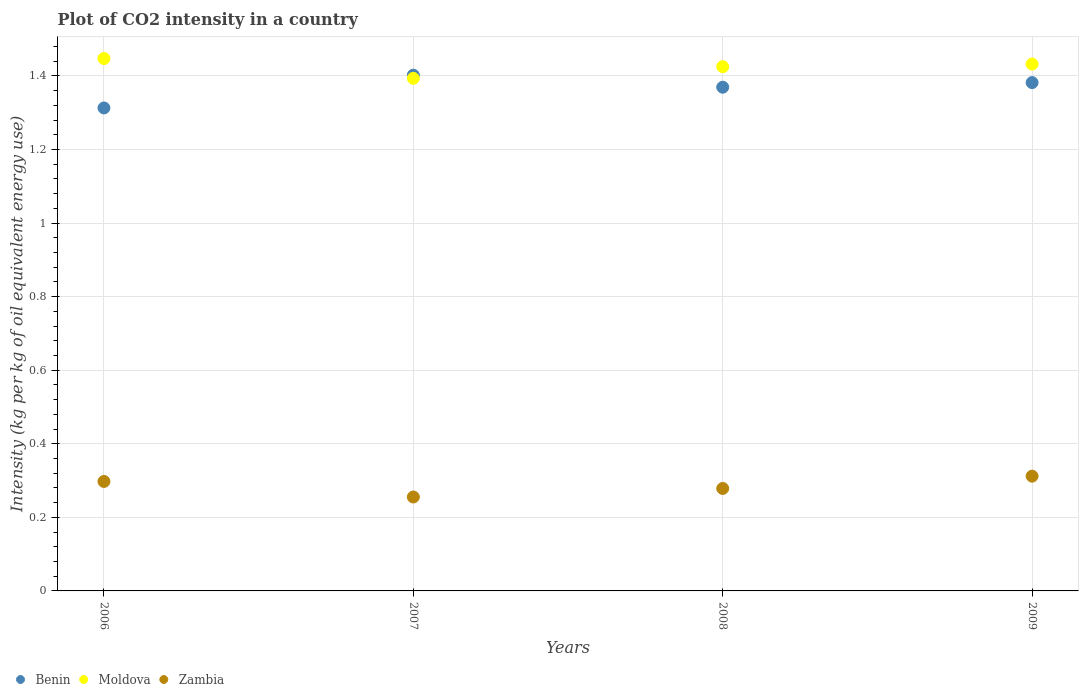What is the CO2 intensity in in Moldova in 2007?
Your response must be concise. 1.39. Across all years, what is the maximum CO2 intensity in in Zambia?
Ensure brevity in your answer.  0.31. Across all years, what is the minimum CO2 intensity in in Benin?
Offer a terse response. 1.31. In which year was the CO2 intensity in in Moldova minimum?
Give a very brief answer. 2007. What is the total CO2 intensity in in Moldova in the graph?
Provide a succinct answer. 5.7. What is the difference between the CO2 intensity in in Zambia in 2006 and that in 2009?
Your answer should be very brief. -0.01. What is the difference between the CO2 intensity in in Moldova in 2008 and the CO2 intensity in in Zambia in 2007?
Your response must be concise. 1.17. What is the average CO2 intensity in in Benin per year?
Your answer should be compact. 1.37. In the year 2007, what is the difference between the CO2 intensity in in Moldova and CO2 intensity in in Zambia?
Offer a terse response. 1.14. In how many years, is the CO2 intensity in in Moldova greater than 0.48000000000000004 kg?
Keep it short and to the point. 4. What is the ratio of the CO2 intensity in in Benin in 2008 to that in 2009?
Keep it short and to the point. 0.99. What is the difference between the highest and the second highest CO2 intensity in in Moldova?
Provide a succinct answer. 0.02. What is the difference between the highest and the lowest CO2 intensity in in Zambia?
Ensure brevity in your answer.  0.06. Is the sum of the CO2 intensity in in Zambia in 2006 and 2009 greater than the maximum CO2 intensity in in Benin across all years?
Ensure brevity in your answer.  No. How many dotlines are there?
Offer a terse response. 3. How many years are there in the graph?
Make the answer very short. 4. What is the difference between two consecutive major ticks on the Y-axis?
Give a very brief answer. 0.2. How are the legend labels stacked?
Your answer should be very brief. Horizontal. What is the title of the graph?
Offer a terse response. Plot of CO2 intensity in a country. What is the label or title of the Y-axis?
Keep it short and to the point. Intensity (kg per kg of oil equivalent energy use). What is the Intensity (kg per kg of oil equivalent energy use) in Benin in 2006?
Offer a very short reply. 1.31. What is the Intensity (kg per kg of oil equivalent energy use) in Moldova in 2006?
Offer a very short reply. 1.45. What is the Intensity (kg per kg of oil equivalent energy use) of Zambia in 2006?
Give a very brief answer. 0.3. What is the Intensity (kg per kg of oil equivalent energy use) of Benin in 2007?
Ensure brevity in your answer.  1.4. What is the Intensity (kg per kg of oil equivalent energy use) of Moldova in 2007?
Ensure brevity in your answer.  1.39. What is the Intensity (kg per kg of oil equivalent energy use) in Zambia in 2007?
Offer a very short reply. 0.26. What is the Intensity (kg per kg of oil equivalent energy use) of Benin in 2008?
Your answer should be compact. 1.37. What is the Intensity (kg per kg of oil equivalent energy use) of Moldova in 2008?
Offer a very short reply. 1.43. What is the Intensity (kg per kg of oil equivalent energy use) in Zambia in 2008?
Your answer should be very brief. 0.28. What is the Intensity (kg per kg of oil equivalent energy use) of Benin in 2009?
Your response must be concise. 1.38. What is the Intensity (kg per kg of oil equivalent energy use) in Moldova in 2009?
Your answer should be compact. 1.43. What is the Intensity (kg per kg of oil equivalent energy use) of Zambia in 2009?
Keep it short and to the point. 0.31. Across all years, what is the maximum Intensity (kg per kg of oil equivalent energy use) in Benin?
Provide a short and direct response. 1.4. Across all years, what is the maximum Intensity (kg per kg of oil equivalent energy use) of Moldova?
Keep it short and to the point. 1.45. Across all years, what is the maximum Intensity (kg per kg of oil equivalent energy use) of Zambia?
Your answer should be very brief. 0.31. Across all years, what is the minimum Intensity (kg per kg of oil equivalent energy use) of Benin?
Provide a succinct answer. 1.31. Across all years, what is the minimum Intensity (kg per kg of oil equivalent energy use) in Moldova?
Give a very brief answer. 1.39. Across all years, what is the minimum Intensity (kg per kg of oil equivalent energy use) in Zambia?
Ensure brevity in your answer.  0.26. What is the total Intensity (kg per kg of oil equivalent energy use) of Benin in the graph?
Give a very brief answer. 5.47. What is the total Intensity (kg per kg of oil equivalent energy use) in Moldova in the graph?
Ensure brevity in your answer.  5.7. What is the total Intensity (kg per kg of oil equivalent energy use) in Zambia in the graph?
Make the answer very short. 1.14. What is the difference between the Intensity (kg per kg of oil equivalent energy use) of Benin in 2006 and that in 2007?
Keep it short and to the point. -0.09. What is the difference between the Intensity (kg per kg of oil equivalent energy use) of Moldova in 2006 and that in 2007?
Offer a terse response. 0.05. What is the difference between the Intensity (kg per kg of oil equivalent energy use) of Zambia in 2006 and that in 2007?
Ensure brevity in your answer.  0.04. What is the difference between the Intensity (kg per kg of oil equivalent energy use) in Benin in 2006 and that in 2008?
Offer a very short reply. -0.06. What is the difference between the Intensity (kg per kg of oil equivalent energy use) in Moldova in 2006 and that in 2008?
Offer a terse response. 0.02. What is the difference between the Intensity (kg per kg of oil equivalent energy use) of Zambia in 2006 and that in 2008?
Your answer should be compact. 0.02. What is the difference between the Intensity (kg per kg of oil equivalent energy use) of Benin in 2006 and that in 2009?
Your answer should be compact. -0.07. What is the difference between the Intensity (kg per kg of oil equivalent energy use) in Moldova in 2006 and that in 2009?
Give a very brief answer. 0.02. What is the difference between the Intensity (kg per kg of oil equivalent energy use) in Zambia in 2006 and that in 2009?
Offer a very short reply. -0.01. What is the difference between the Intensity (kg per kg of oil equivalent energy use) of Benin in 2007 and that in 2008?
Your answer should be compact. 0.03. What is the difference between the Intensity (kg per kg of oil equivalent energy use) of Moldova in 2007 and that in 2008?
Provide a succinct answer. -0.03. What is the difference between the Intensity (kg per kg of oil equivalent energy use) of Zambia in 2007 and that in 2008?
Your response must be concise. -0.02. What is the difference between the Intensity (kg per kg of oil equivalent energy use) in Benin in 2007 and that in 2009?
Offer a terse response. 0.02. What is the difference between the Intensity (kg per kg of oil equivalent energy use) in Moldova in 2007 and that in 2009?
Offer a very short reply. -0.04. What is the difference between the Intensity (kg per kg of oil equivalent energy use) of Zambia in 2007 and that in 2009?
Offer a terse response. -0.06. What is the difference between the Intensity (kg per kg of oil equivalent energy use) of Benin in 2008 and that in 2009?
Offer a very short reply. -0.01. What is the difference between the Intensity (kg per kg of oil equivalent energy use) of Moldova in 2008 and that in 2009?
Offer a terse response. -0.01. What is the difference between the Intensity (kg per kg of oil equivalent energy use) in Zambia in 2008 and that in 2009?
Provide a short and direct response. -0.03. What is the difference between the Intensity (kg per kg of oil equivalent energy use) in Benin in 2006 and the Intensity (kg per kg of oil equivalent energy use) in Moldova in 2007?
Your answer should be very brief. -0.08. What is the difference between the Intensity (kg per kg of oil equivalent energy use) in Benin in 2006 and the Intensity (kg per kg of oil equivalent energy use) in Zambia in 2007?
Give a very brief answer. 1.06. What is the difference between the Intensity (kg per kg of oil equivalent energy use) in Moldova in 2006 and the Intensity (kg per kg of oil equivalent energy use) in Zambia in 2007?
Your answer should be compact. 1.19. What is the difference between the Intensity (kg per kg of oil equivalent energy use) of Benin in 2006 and the Intensity (kg per kg of oil equivalent energy use) of Moldova in 2008?
Your response must be concise. -0.11. What is the difference between the Intensity (kg per kg of oil equivalent energy use) in Benin in 2006 and the Intensity (kg per kg of oil equivalent energy use) in Zambia in 2008?
Make the answer very short. 1.03. What is the difference between the Intensity (kg per kg of oil equivalent energy use) of Moldova in 2006 and the Intensity (kg per kg of oil equivalent energy use) of Zambia in 2008?
Offer a very short reply. 1.17. What is the difference between the Intensity (kg per kg of oil equivalent energy use) of Benin in 2006 and the Intensity (kg per kg of oil equivalent energy use) of Moldova in 2009?
Offer a terse response. -0.12. What is the difference between the Intensity (kg per kg of oil equivalent energy use) in Benin in 2006 and the Intensity (kg per kg of oil equivalent energy use) in Zambia in 2009?
Ensure brevity in your answer.  1. What is the difference between the Intensity (kg per kg of oil equivalent energy use) of Moldova in 2006 and the Intensity (kg per kg of oil equivalent energy use) of Zambia in 2009?
Provide a short and direct response. 1.14. What is the difference between the Intensity (kg per kg of oil equivalent energy use) in Benin in 2007 and the Intensity (kg per kg of oil equivalent energy use) in Moldova in 2008?
Your response must be concise. -0.02. What is the difference between the Intensity (kg per kg of oil equivalent energy use) of Benin in 2007 and the Intensity (kg per kg of oil equivalent energy use) of Zambia in 2008?
Keep it short and to the point. 1.12. What is the difference between the Intensity (kg per kg of oil equivalent energy use) of Moldova in 2007 and the Intensity (kg per kg of oil equivalent energy use) of Zambia in 2008?
Your response must be concise. 1.12. What is the difference between the Intensity (kg per kg of oil equivalent energy use) of Benin in 2007 and the Intensity (kg per kg of oil equivalent energy use) of Moldova in 2009?
Your answer should be compact. -0.03. What is the difference between the Intensity (kg per kg of oil equivalent energy use) in Benin in 2007 and the Intensity (kg per kg of oil equivalent energy use) in Zambia in 2009?
Provide a succinct answer. 1.09. What is the difference between the Intensity (kg per kg of oil equivalent energy use) of Moldova in 2007 and the Intensity (kg per kg of oil equivalent energy use) of Zambia in 2009?
Keep it short and to the point. 1.08. What is the difference between the Intensity (kg per kg of oil equivalent energy use) of Benin in 2008 and the Intensity (kg per kg of oil equivalent energy use) of Moldova in 2009?
Offer a terse response. -0.06. What is the difference between the Intensity (kg per kg of oil equivalent energy use) in Benin in 2008 and the Intensity (kg per kg of oil equivalent energy use) in Zambia in 2009?
Keep it short and to the point. 1.06. What is the difference between the Intensity (kg per kg of oil equivalent energy use) of Moldova in 2008 and the Intensity (kg per kg of oil equivalent energy use) of Zambia in 2009?
Offer a very short reply. 1.11. What is the average Intensity (kg per kg of oil equivalent energy use) in Benin per year?
Your answer should be very brief. 1.37. What is the average Intensity (kg per kg of oil equivalent energy use) in Moldova per year?
Provide a short and direct response. 1.42. What is the average Intensity (kg per kg of oil equivalent energy use) of Zambia per year?
Give a very brief answer. 0.29. In the year 2006, what is the difference between the Intensity (kg per kg of oil equivalent energy use) in Benin and Intensity (kg per kg of oil equivalent energy use) in Moldova?
Offer a very short reply. -0.13. In the year 2006, what is the difference between the Intensity (kg per kg of oil equivalent energy use) of Benin and Intensity (kg per kg of oil equivalent energy use) of Zambia?
Offer a terse response. 1.02. In the year 2006, what is the difference between the Intensity (kg per kg of oil equivalent energy use) in Moldova and Intensity (kg per kg of oil equivalent energy use) in Zambia?
Make the answer very short. 1.15. In the year 2007, what is the difference between the Intensity (kg per kg of oil equivalent energy use) of Benin and Intensity (kg per kg of oil equivalent energy use) of Moldova?
Provide a succinct answer. 0.01. In the year 2007, what is the difference between the Intensity (kg per kg of oil equivalent energy use) of Benin and Intensity (kg per kg of oil equivalent energy use) of Zambia?
Keep it short and to the point. 1.15. In the year 2007, what is the difference between the Intensity (kg per kg of oil equivalent energy use) of Moldova and Intensity (kg per kg of oil equivalent energy use) of Zambia?
Your answer should be compact. 1.14. In the year 2008, what is the difference between the Intensity (kg per kg of oil equivalent energy use) in Benin and Intensity (kg per kg of oil equivalent energy use) in Moldova?
Your answer should be very brief. -0.06. In the year 2008, what is the difference between the Intensity (kg per kg of oil equivalent energy use) of Moldova and Intensity (kg per kg of oil equivalent energy use) of Zambia?
Ensure brevity in your answer.  1.15. In the year 2009, what is the difference between the Intensity (kg per kg of oil equivalent energy use) in Benin and Intensity (kg per kg of oil equivalent energy use) in Moldova?
Ensure brevity in your answer.  -0.05. In the year 2009, what is the difference between the Intensity (kg per kg of oil equivalent energy use) of Benin and Intensity (kg per kg of oil equivalent energy use) of Zambia?
Your answer should be compact. 1.07. In the year 2009, what is the difference between the Intensity (kg per kg of oil equivalent energy use) in Moldova and Intensity (kg per kg of oil equivalent energy use) in Zambia?
Your answer should be very brief. 1.12. What is the ratio of the Intensity (kg per kg of oil equivalent energy use) in Benin in 2006 to that in 2007?
Offer a very short reply. 0.94. What is the ratio of the Intensity (kg per kg of oil equivalent energy use) of Moldova in 2006 to that in 2007?
Give a very brief answer. 1.04. What is the ratio of the Intensity (kg per kg of oil equivalent energy use) of Zambia in 2006 to that in 2007?
Offer a very short reply. 1.17. What is the ratio of the Intensity (kg per kg of oil equivalent energy use) in Benin in 2006 to that in 2008?
Offer a terse response. 0.96. What is the ratio of the Intensity (kg per kg of oil equivalent energy use) of Moldova in 2006 to that in 2008?
Make the answer very short. 1.02. What is the ratio of the Intensity (kg per kg of oil equivalent energy use) in Zambia in 2006 to that in 2008?
Offer a very short reply. 1.07. What is the ratio of the Intensity (kg per kg of oil equivalent energy use) in Benin in 2006 to that in 2009?
Offer a very short reply. 0.95. What is the ratio of the Intensity (kg per kg of oil equivalent energy use) in Moldova in 2006 to that in 2009?
Offer a terse response. 1.01. What is the ratio of the Intensity (kg per kg of oil equivalent energy use) in Zambia in 2006 to that in 2009?
Give a very brief answer. 0.95. What is the ratio of the Intensity (kg per kg of oil equivalent energy use) in Benin in 2007 to that in 2008?
Give a very brief answer. 1.02. What is the ratio of the Intensity (kg per kg of oil equivalent energy use) in Moldova in 2007 to that in 2008?
Your answer should be compact. 0.98. What is the ratio of the Intensity (kg per kg of oil equivalent energy use) of Zambia in 2007 to that in 2008?
Keep it short and to the point. 0.92. What is the ratio of the Intensity (kg per kg of oil equivalent energy use) in Benin in 2007 to that in 2009?
Make the answer very short. 1.01. What is the ratio of the Intensity (kg per kg of oil equivalent energy use) in Zambia in 2007 to that in 2009?
Offer a very short reply. 0.82. What is the ratio of the Intensity (kg per kg of oil equivalent energy use) in Benin in 2008 to that in 2009?
Provide a succinct answer. 0.99. What is the ratio of the Intensity (kg per kg of oil equivalent energy use) in Moldova in 2008 to that in 2009?
Your response must be concise. 0.99. What is the ratio of the Intensity (kg per kg of oil equivalent energy use) in Zambia in 2008 to that in 2009?
Your answer should be compact. 0.89. What is the difference between the highest and the second highest Intensity (kg per kg of oil equivalent energy use) of Benin?
Your answer should be very brief. 0.02. What is the difference between the highest and the second highest Intensity (kg per kg of oil equivalent energy use) in Moldova?
Make the answer very short. 0.02. What is the difference between the highest and the second highest Intensity (kg per kg of oil equivalent energy use) in Zambia?
Keep it short and to the point. 0.01. What is the difference between the highest and the lowest Intensity (kg per kg of oil equivalent energy use) in Benin?
Ensure brevity in your answer.  0.09. What is the difference between the highest and the lowest Intensity (kg per kg of oil equivalent energy use) of Moldova?
Your answer should be compact. 0.05. What is the difference between the highest and the lowest Intensity (kg per kg of oil equivalent energy use) in Zambia?
Make the answer very short. 0.06. 